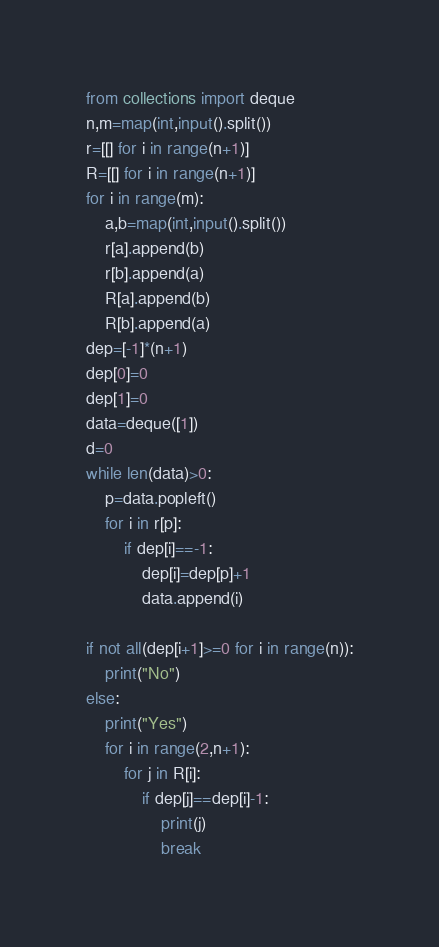<code> <loc_0><loc_0><loc_500><loc_500><_Python_>from collections import deque
n,m=map(int,input().split())
r=[[] for i in range(n+1)]
R=[[] for i in range(n+1)]
for i in range(m):
    a,b=map(int,input().split())
    r[a].append(b)
    r[b].append(a)
    R[a].append(b)
    R[b].append(a)
dep=[-1]*(n+1)
dep[0]=0
dep[1]=0
data=deque([1])
d=0
while len(data)>0:
    p=data.popleft()
    for i in r[p]:
        if dep[i]==-1:
            dep[i]=dep[p]+1
            data.append(i)
    
if not all(dep[i+1]>=0 for i in range(n)):
    print("No")
else:
    print("Yes")
    for i in range(2,n+1):
        for j in R[i]:
            if dep[j]==dep[i]-1:
                print(j)
                break
</code> 